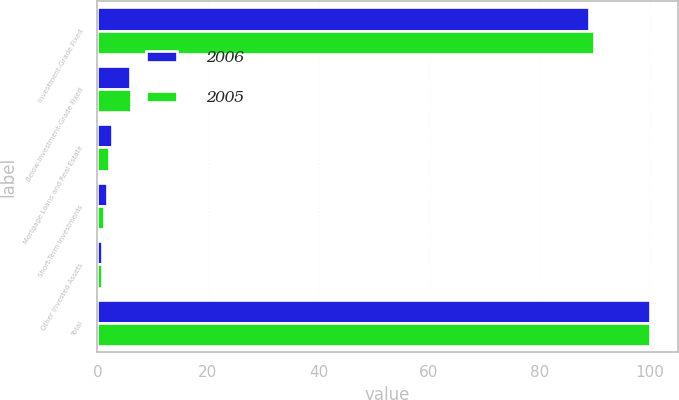Convert chart. <chart><loc_0><loc_0><loc_500><loc_500><stacked_bar_chart><ecel><fcel>Investment-Grade Fixed<fcel>Below-Investment-Grade Fixed<fcel>Mortgage Loans and Real Estate<fcel>Short-Term Investments<fcel>Other Invested Assets<fcel>Total<nl><fcel>2006<fcel>89<fcel>5.8<fcel>2.6<fcel>1.8<fcel>0.8<fcel>100<nl><fcel>2005<fcel>89.9<fcel>6<fcel>2.1<fcel>1.2<fcel>0.8<fcel>100<nl></chart> 